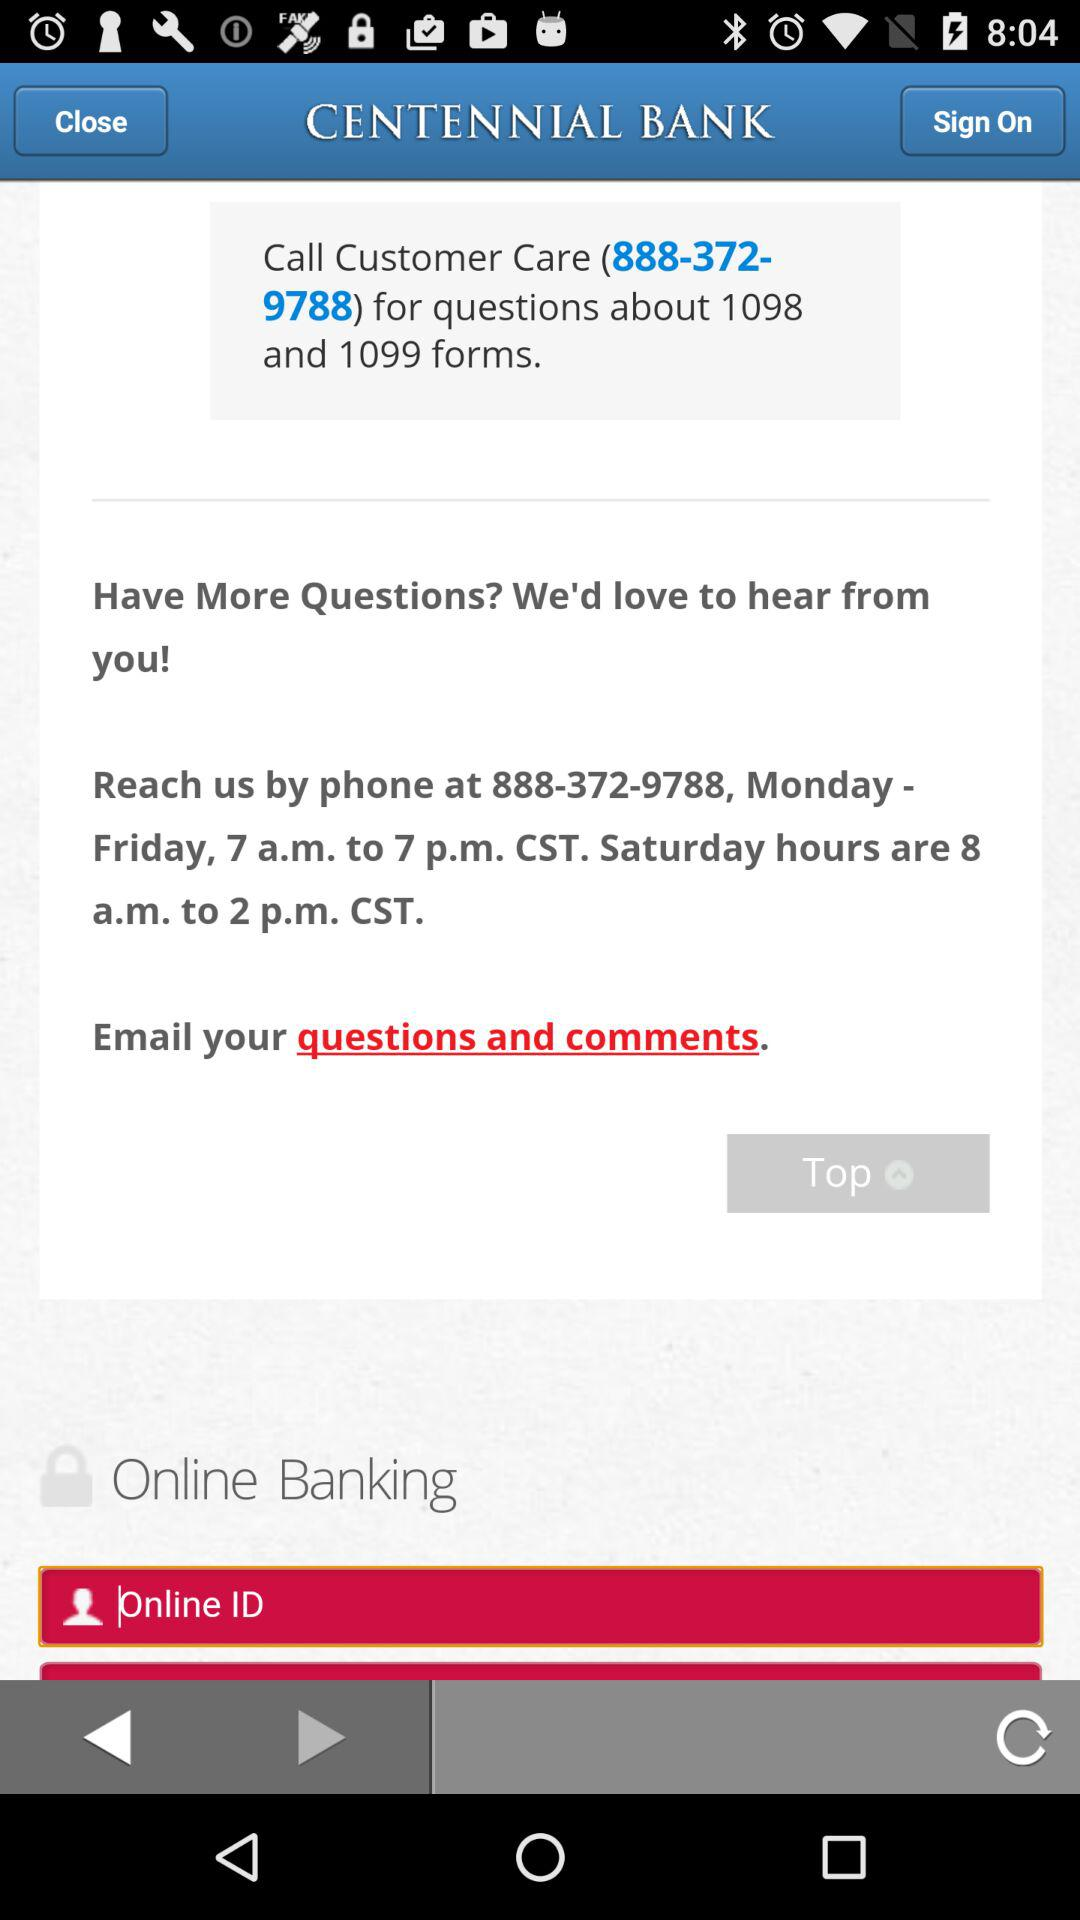Where is Centennial Bank located?
When the provided information is insufficient, respond with <no answer>. <no answer> 